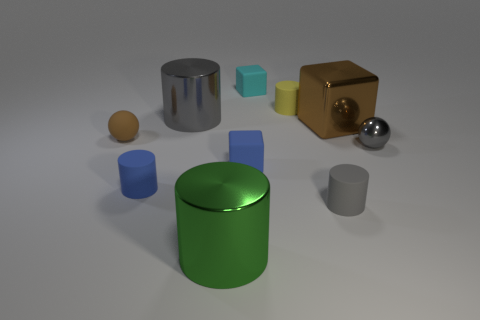Are there any balls made of the same material as the cyan object?
Provide a short and direct response. Yes. There is a green metal thing that is the same shape as the big gray object; what size is it?
Give a very brief answer. Large. Are there the same number of large blocks in front of the small gray metallic sphere and small cyan cubes?
Your answer should be very brief. No. There is a blue rubber thing that is left of the gray metallic cylinder; does it have the same shape as the tiny brown object?
Keep it short and to the point. No. The gray rubber object is what shape?
Ensure brevity in your answer.  Cylinder. What is the material of the brown thing that is on the right side of the tiny gray thing in front of the tiny blue matte object in front of the blue matte block?
Offer a terse response. Metal. There is a big block that is the same color as the rubber ball; what is it made of?
Give a very brief answer. Metal. How many things are big metal things or brown things?
Offer a very short reply. 4. Is the tiny ball that is to the right of the brown sphere made of the same material as the tiny yellow thing?
Offer a terse response. No. What number of objects are either matte cylinders that are in front of the tiny blue cylinder or small yellow matte objects?
Provide a short and direct response. 2. 